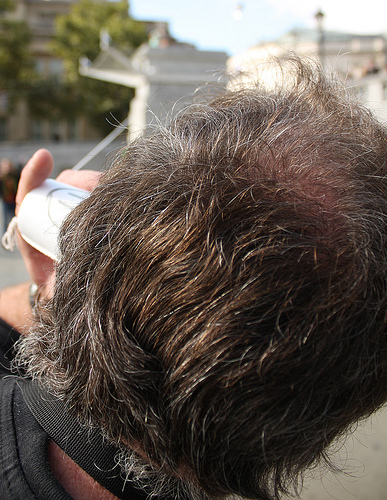<image>
Is the strap behind the head? No. The strap is not behind the head. From this viewpoint, the strap appears to be positioned elsewhere in the scene. 